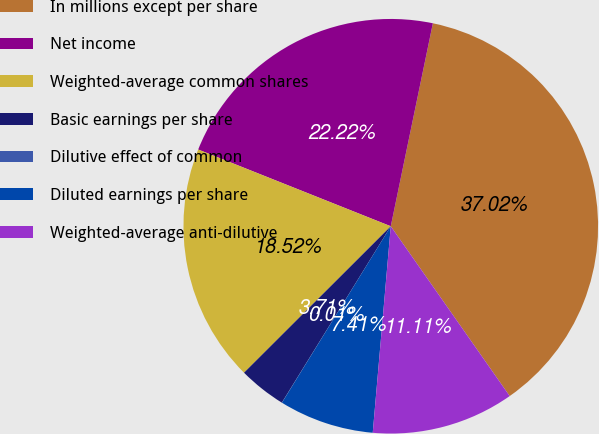Convert chart to OTSL. <chart><loc_0><loc_0><loc_500><loc_500><pie_chart><fcel>In millions except per share<fcel>Net income<fcel>Weighted-average common shares<fcel>Basic earnings per share<fcel>Dilutive effect of common<fcel>Diluted earnings per share<fcel>Weighted-average anti-dilutive<nl><fcel>37.02%<fcel>22.22%<fcel>18.52%<fcel>3.71%<fcel>0.01%<fcel>7.41%<fcel>11.11%<nl></chart> 